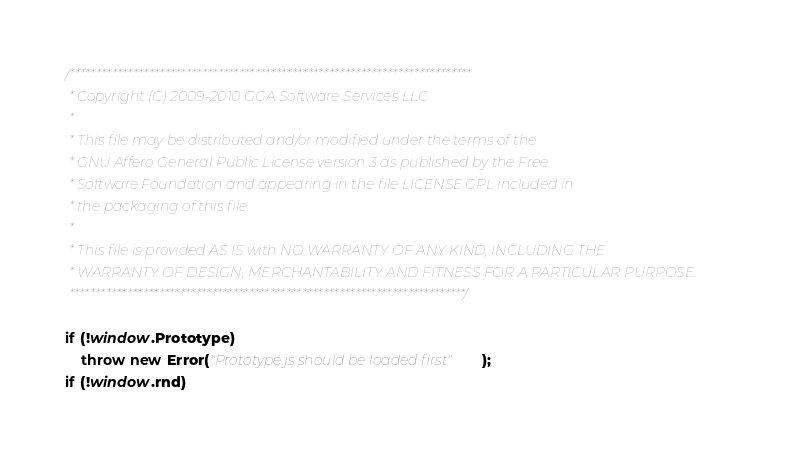<code> <loc_0><loc_0><loc_500><loc_500><_JavaScript_>/****************************************************************************
 * Copyright (C) 2009-2010 GGA Software Services LLC
 *
 * This file may be distributed and/or modified under the terms of the
 * GNU Affero General Public License version 3 as published by the Free
 * Software Foundation and appearing in the file LICENSE.GPL included in
 * the packaging of this file.
 *
 * This file is provided AS IS with NO WARRANTY OF ANY KIND, INCLUDING THE
 * WARRANTY OF DESIGN, MERCHANTABILITY AND FITNESS FOR A PARTICULAR PURPOSE.
 ***************************************************************************/

if (!window.Prototype)
	throw new Error("Prototype.js should be loaded first");
if (!window.rnd)</code> 